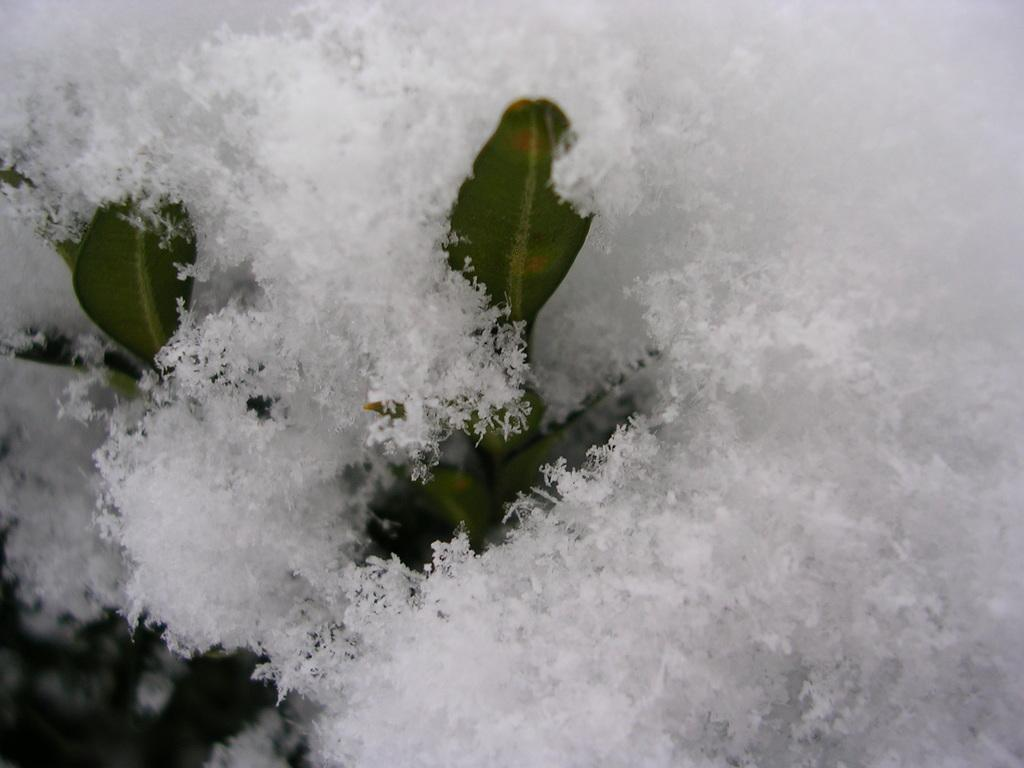What type of natural elements can be seen in the image? There are leaves in the image. What color is the object in the image? There is a white color object in the image. How many legs can be seen on the flag in the image? There is no flag present in the image, and therefore no legs can be seen on a flag. 